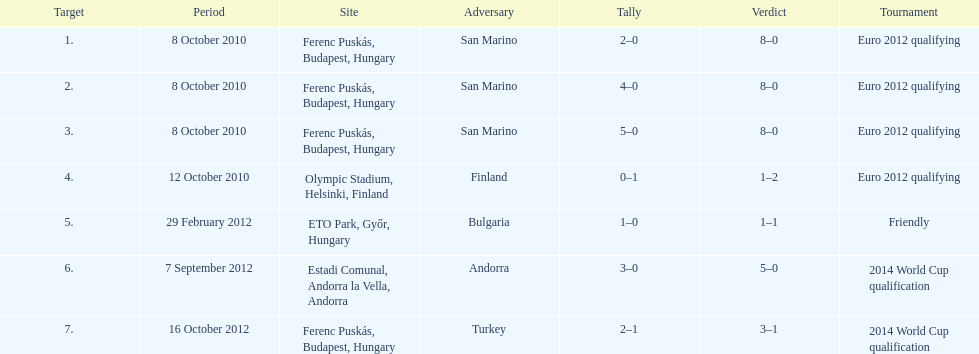Szalai scored all but one of his international goals in either euro 2012 qualifying or what other level of play? 2014 World Cup qualification. 